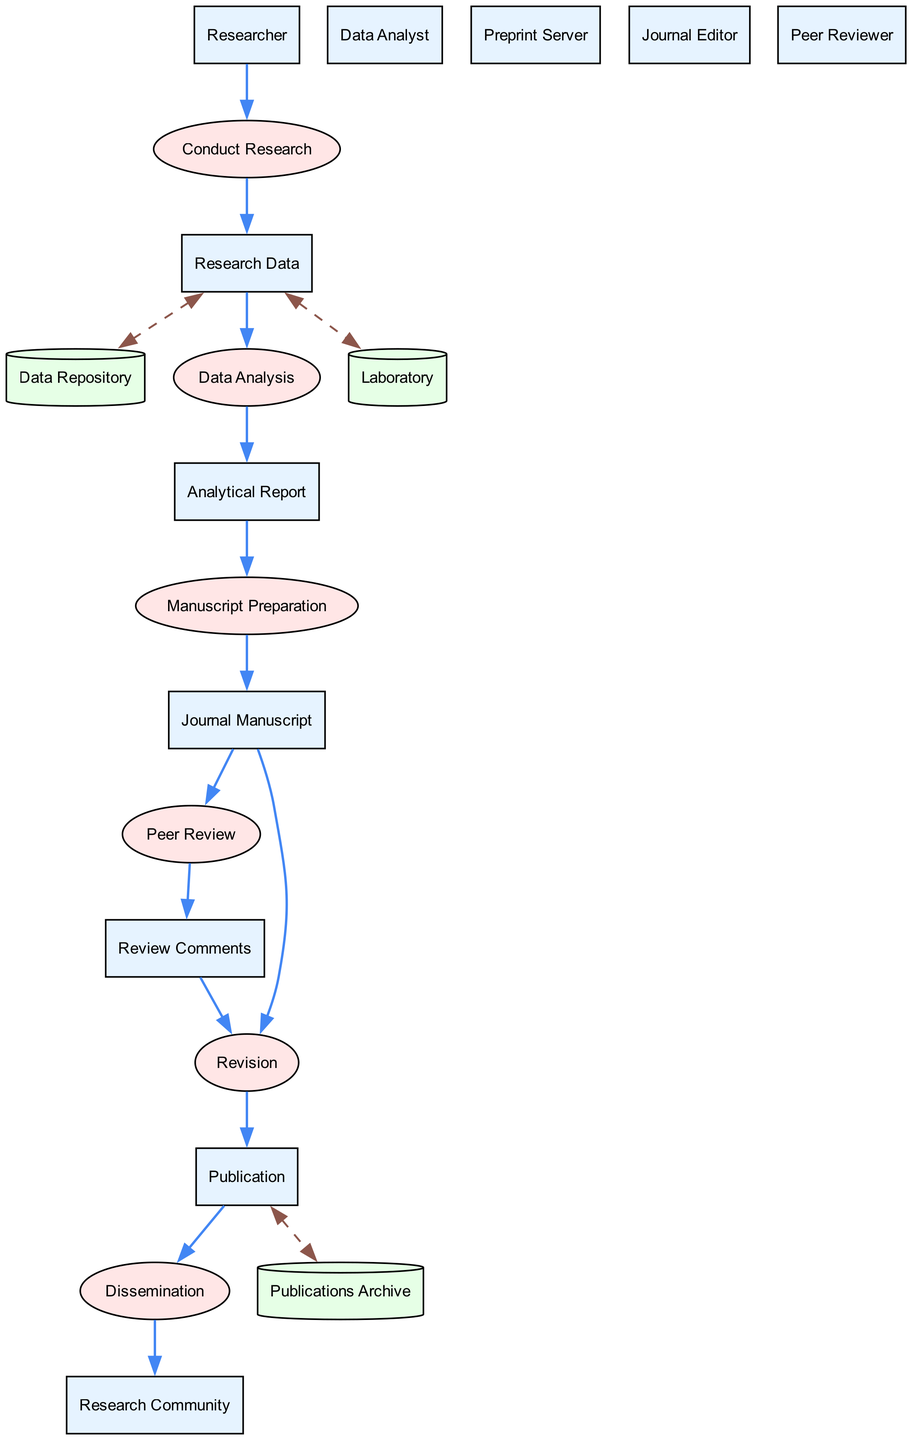What entities are present in the diagram? The diagram includes multiple entities, namely: Researcher, Research Data, Data Repository, Data Analyst, Analytical Report, Journal Manuscript, Preprint Server, Journal Editor, Peer Reviewer, Review Comments, Publication, and Research Community. Each of these is labeled as an entity in the diagram.
Answer: Researcher, Research Data, Data Repository, Data Analyst, Analytical Report, Journal Manuscript, Preprint Server, Journal Editor, Peer Reviewer, Review Comments, Publication, Research Community What is the output of the "Data Analysis" process? The "Data Analysis" process takes Research Data as input and produces an Analytical Report as output. This relationship is clearly established in the diagram as it outlines inputs and outputs for each process.
Answer: Analytical Report How many data stores are shown in the diagram? There are three data stores represented in the diagram: Laboratory, Data Repository, and Publications Archive. Counting these elements provides a clear answer.
Answer: Three Which document is written using the Analytical Report? The Journal Manuscript is prepared using the Analytical Report. The diagram indicates this through the input-output relationship of the Manuscript Preparation process.
Answer: Journal Manuscript What generates Review Comments in the diagram? Review Comments are produced by the Peer Reviewer upon receiving the Journal Manuscript. This flow is depicted in the Peer Review process, indicating the reviewer’s role in the feedback loop.
Answer: Peer Reviewer What is the final output after the Revision process? The output of the Revision process is the Publication. This is derived from understanding the flow from the Revision process which incorporates the Journal Manuscript and Review Comments and leads to the final published research paper.
Answer: Publication What process follows the Peer Review process? The process that follows the Peer Review process is Revision, as indicated by the output of Review Comments feeding into the Revision process to produce the final Publication.
Answer: Revision How does the Research Community access published research? The Research Community accesses published research through the Dissemination process, as indicated in the diagram where Publication is the input leading to the output of Research Community.
Answer: Dissemination What role does the Journal Editor have in the manuscript process? The Journal Editor receives the Journal Manuscript and assigns a Peer Reviewer, as depicted in the diagram which outlines the editor's responsibility in the peer review system.
Answer: Assigns Peer Reviewer 